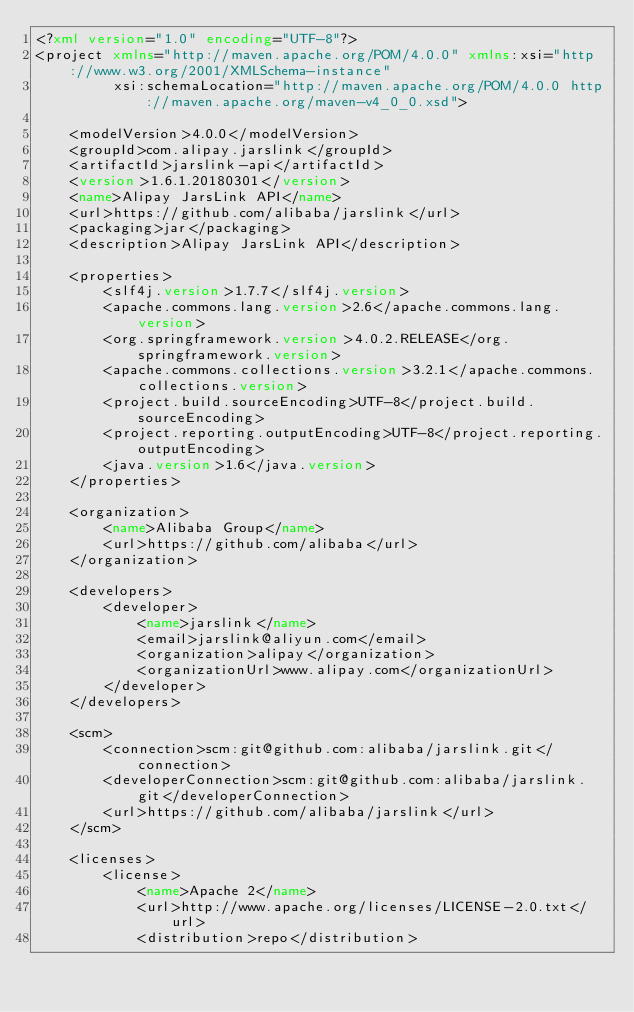Convert code to text. <code><loc_0><loc_0><loc_500><loc_500><_XML_><?xml version="1.0" encoding="UTF-8"?>
<project xmlns="http://maven.apache.org/POM/4.0.0" xmlns:xsi="http://www.w3.org/2001/XMLSchema-instance"
         xsi:schemaLocation="http://maven.apache.org/POM/4.0.0 http://maven.apache.org/maven-v4_0_0.xsd">

    <modelVersion>4.0.0</modelVersion>
    <groupId>com.alipay.jarslink</groupId>
    <artifactId>jarslink-api</artifactId>
    <version>1.6.1.20180301</version>
    <name>Alipay JarsLink API</name>
    <url>https://github.com/alibaba/jarslink</url>
    <packaging>jar</packaging>
    <description>Alipay JarsLink API</description>

    <properties>
        <slf4j.version>1.7.7</slf4j.version>
        <apache.commons.lang.version>2.6</apache.commons.lang.version>
        <org.springframework.version>4.0.2.RELEASE</org.springframework.version>
        <apache.commons.collections.version>3.2.1</apache.commons.collections.version>
        <project.build.sourceEncoding>UTF-8</project.build.sourceEncoding>
        <project.reporting.outputEncoding>UTF-8</project.reporting.outputEncoding>
        <java.version>1.6</java.version>
    </properties>

    <organization>
        <name>Alibaba Group</name>
        <url>https://github.com/alibaba</url>
    </organization>

    <developers>
        <developer>
            <name>jarslink</name>
            <email>jarslink@aliyun.com</email>
            <organization>alipay</organization>
            <organizationUrl>www.alipay.com</organizationUrl>
        </developer>
    </developers>

    <scm>
        <connection>scm:git@github.com:alibaba/jarslink.git</connection>
        <developerConnection>scm:git@github.com:alibaba/jarslink.git</developerConnection>
        <url>https://github.com/alibaba/jarslink</url>
    </scm>

    <licenses>
        <license>
            <name>Apache 2</name>
            <url>http://www.apache.org/licenses/LICENSE-2.0.txt</url>
            <distribution>repo</distribution></code> 